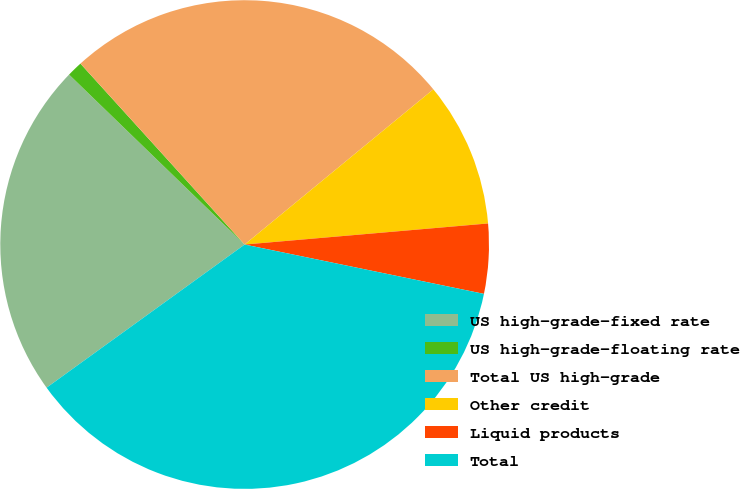<chart> <loc_0><loc_0><loc_500><loc_500><pie_chart><fcel>US high-grade-fixed rate<fcel>US high-grade-floating rate<fcel>Total US high-grade<fcel>Other credit<fcel>Liquid products<fcel>Total<nl><fcel>22.2%<fcel>1.03%<fcel>25.77%<fcel>9.58%<fcel>4.61%<fcel>36.8%<nl></chart> 